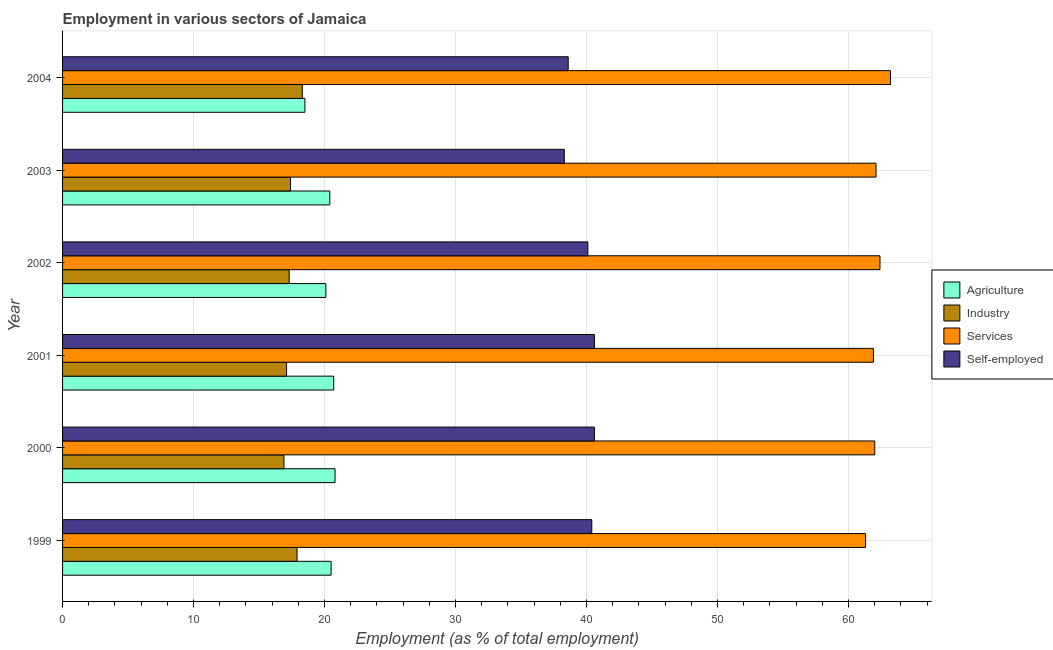How many different coloured bars are there?
Your answer should be very brief. 4. Are the number of bars per tick equal to the number of legend labels?
Provide a succinct answer. Yes. How many bars are there on the 1st tick from the top?
Provide a succinct answer. 4. How many bars are there on the 2nd tick from the bottom?
Give a very brief answer. 4. What is the label of the 3rd group of bars from the top?
Your response must be concise. 2002. In how many cases, is the number of bars for a given year not equal to the number of legend labels?
Offer a very short reply. 0. Across all years, what is the maximum percentage of workers in industry?
Ensure brevity in your answer.  18.3. In which year was the percentage of self employed workers maximum?
Your response must be concise. 2000. In which year was the percentage of workers in services minimum?
Offer a very short reply. 1999. What is the total percentage of workers in services in the graph?
Your response must be concise. 372.9. What is the difference between the percentage of workers in services in 2000 and that in 2003?
Ensure brevity in your answer.  -0.1. What is the difference between the percentage of self employed workers in 2000 and the percentage of workers in agriculture in 2004?
Your answer should be compact. 22.1. What is the average percentage of workers in services per year?
Your response must be concise. 62.15. In the year 2002, what is the difference between the percentage of workers in agriculture and percentage of self employed workers?
Ensure brevity in your answer.  -20. In how many years, is the percentage of workers in agriculture greater than 56 %?
Give a very brief answer. 0. What is the ratio of the percentage of workers in agriculture in 2002 to that in 2004?
Keep it short and to the point. 1.09. What is the difference between the highest and the second highest percentage of workers in industry?
Offer a terse response. 0.4. Is it the case that in every year, the sum of the percentage of self employed workers and percentage of workers in industry is greater than the sum of percentage of workers in services and percentage of workers in agriculture?
Ensure brevity in your answer.  Yes. What does the 4th bar from the top in 2004 represents?
Offer a very short reply. Agriculture. What does the 4th bar from the bottom in 2001 represents?
Ensure brevity in your answer.  Self-employed. How many bars are there?
Your response must be concise. 24. What is the difference between two consecutive major ticks on the X-axis?
Provide a succinct answer. 10. Does the graph contain grids?
Make the answer very short. Yes. Where does the legend appear in the graph?
Your answer should be very brief. Center right. How many legend labels are there?
Provide a short and direct response. 4. What is the title of the graph?
Provide a short and direct response. Employment in various sectors of Jamaica. What is the label or title of the X-axis?
Your answer should be very brief. Employment (as % of total employment). What is the Employment (as % of total employment) of Industry in 1999?
Keep it short and to the point. 17.9. What is the Employment (as % of total employment) of Services in 1999?
Provide a short and direct response. 61.3. What is the Employment (as % of total employment) in Self-employed in 1999?
Your response must be concise. 40.4. What is the Employment (as % of total employment) in Agriculture in 2000?
Your response must be concise. 20.8. What is the Employment (as % of total employment) in Industry in 2000?
Provide a succinct answer. 16.9. What is the Employment (as % of total employment) of Services in 2000?
Ensure brevity in your answer.  62. What is the Employment (as % of total employment) of Self-employed in 2000?
Your response must be concise. 40.6. What is the Employment (as % of total employment) in Agriculture in 2001?
Provide a short and direct response. 20.7. What is the Employment (as % of total employment) of Industry in 2001?
Provide a short and direct response. 17.1. What is the Employment (as % of total employment) in Services in 2001?
Your response must be concise. 61.9. What is the Employment (as % of total employment) in Self-employed in 2001?
Keep it short and to the point. 40.6. What is the Employment (as % of total employment) of Agriculture in 2002?
Provide a succinct answer. 20.1. What is the Employment (as % of total employment) in Industry in 2002?
Give a very brief answer. 17.3. What is the Employment (as % of total employment) in Services in 2002?
Keep it short and to the point. 62.4. What is the Employment (as % of total employment) in Self-employed in 2002?
Provide a succinct answer. 40.1. What is the Employment (as % of total employment) in Agriculture in 2003?
Give a very brief answer. 20.4. What is the Employment (as % of total employment) in Industry in 2003?
Keep it short and to the point. 17.4. What is the Employment (as % of total employment) of Services in 2003?
Your answer should be compact. 62.1. What is the Employment (as % of total employment) in Self-employed in 2003?
Give a very brief answer. 38.3. What is the Employment (as % of total employment) of Agriculture in 2004?
Make the answer very short. 18.5. What is the Employment (as % of total employment) of Industry in 2004?
Offer a terse response. 18.3. What is the Employment (as % of total employment) of Services in 2004?
Offer a very short reply. 63.2. What is the Employment (as % of total employment) of Self-employed in 2004?
Offer a terse response. 38.6. Across all years, what is the maximum Employment (as % of total employment) of Agriculture?
Ensure brevity in your answer.  20.8. Across all years, what is the maximum Employment (as % of total employment) in Industry?
Provide a short and direct response. 18.3. Across all years, what is the maximum Employment (as % of total employment) of Services?
Keep it short and to the point. 63.2. Across all years, what is the maximum Employment (as % of total employment) of Self-employed?
Offer a very short reply. 40.6. Across all years, what is the minimum Employment (as % of total employment) of Industry?
Keep it short and to the point. 16.9. Across all years, what is the minimum Employment (as % of total employment) in Services?
Offer a terse response. 61.3. Across all years, what is the minimum Employment (as % of total employment) in Self-employed?
Your answer should be compact. 38.3. What is the total Employment (as % of total employment) of Agriculture in the graph?
Provide a succinct answer. 121. What is the total Employment (as % of total employment) in Industry in the graph?
Keep it short and to the point. 104.9. What is the total Employment (as % of total employment) of Services in the graph?
Offer a terse response. 372.9. What is the total Employment (as % of total employment) of Self-employed in the graph?
Offer a very short reply. 238.6. What is the difference between the Employment (as % of total employment) of Services in 1999 and that in 2000?
Give a very brief answer. -0.7. What is the difference between the Employment (as % of total employment) in Industry in 1999 and that in 2001?
Offer a terse response. 0.8. What is the difference between the Employment (as % of total employment) in Agriculture in 1999 and that in 2002?
Provide a succinct answer. 0.4. What is the difference between the Employment (as % of total employment) in Industry in 1999 and that in 2002?
Provide a succinct answer. 0.6. What is the difference between the Employment (as % of total employment) in Self-employed in 1999 and that in 2002?
Keep it short and to the point. 0.3. What is the difference between the Employment (as % of total employment) of Agriculture in 1999 and that in 2003?
Provide a short and direct response. 0.1. What is the difference between the Employment (as % of total employment) in Industry in 1999 and that in 2003?
Your answer should be compact. 0.5. What is the difference between the Employment (as % of total employment) of Self-employed in 1999 and that in 2003?
Your answer should be compact. 2.1. What is the difference between the Employment (as % of total employment) in Industry in 1999 and that in 2004?
Ensure brevity in your answer.  -0.4. What is the difference between the Employment (as % of total employment) in Self-employed in 1999 and that in 2004?
Ensure brevity in your answer.  1.8. What is the difference between the Employment (as % of total employment) in Industry in 2000 and that in 2001?
Keep it short and to the point. -0.2. What is the difference between the Employment (as % of total employment) of Services in 2000 and that in 2001?
Provide a succinct answer. 0.1. What is the difference between the Employment (as % of total employment) in Agriculture in 2000 and that in 2002?
Provide a succinct answer. 0.7. What is the difference between the Employment (as % of total employment) in Industry in 2000 and that in 2002?
Your response must be concise. -0.4. What is the difference between the Employment (as % of total employment) in Self-employed in 2000 and that in 2002?
Provide a succinct answer. 0.5. What is the difference between the Employment (as % of total employment) of Agriculture in 2000 and that in 2003?
Provide a short and direct response. 0.4. What is the difference between the Employment (as % of total employment) of Self-employed in 2000 and that in 2003?
Ensure brevity in your answer.  2.3. What is the difference between the Employment (as % of total employment) in Agriculture in 2000 and that in 2004?
Ensure brevity in your answer.  2.3. What is the difference between the Employment (as % of total employment) in Industry in 2000 and that in 2004?
Make the answer very short. -1.4. What is the difference between the Employment (as % of total employment) in Industry in 2001 and that in 2002?
Give a very brief answer. -0.2. What is the difference between the Employment (as % of total employment) in Services in 2001 and that in 2002?
Your response must be concise. -0.5. What is the difference between the Employment (as % of total employment) of Self-employed in 2001 and that in 2002?
Offer a very short reply. 0.5. What is the difference between the Employment (as % of total employment) of Agriculture in 2001 and that in 2004?
Your response must be concise. 2.2. What is the difference between the Employment (as % of total employment) in Industry in 2002 and that in 2003?
Your answer should be compact. -0.1. What is the difference between the Employment (as % of total employment) of Services in 2002 and that in 2003?
Ensure brevity in your answer.  0.3. What is the difference between the Employment (as % of total employment) in Services in 2002 and that in 2004?
Your answer should be very brief. -0.8. What is the difference between the Employment (as % of total employment) in Services in 2003 and that in 2004?
Provide a short and direct response. -1.1. What is the difference between the Employment (as % of total employment) of Self-employed in 2003 and that in 2004?
Keep it short and to the point. -0.3. What is the difference between the Employment (as % of total employment) in Agriculture in 1999 and the Employment (as % of total employment) in Industry in 2000?
Offer a very short reply. 3.6. What is the difference between the Employment (as % of total employment) in Agriculture in 1999 and the Employment (as % of total employment) in Services in 2000?
Provide a succinct answer. -41.5. What is the difference between the Employment (as % of total employment) of Agriculture in 1999 and the Employment (as % of total employment) of Self-employed in 2000?
Keep it short and to the point. -20.1. What is the difference between the Employment (as % of total employment) in Industry in 1999 and the Employment (as % of total employment) in Services in 2000?
Offer a terse response. -44.1. What is the difference between the Employment (as % of total employment) of Industry in 1999 and the Employment (as % of total employment) of Self-employed in 2000?
Keep it short and to the point. -22.7. What is the difference between the Employment (as % of total employment) of Services in 1999 and the Employment (as % of total employment) of Self-employed in 2000?
Provide a succinct answer. 20.7. What is the difference between the Employment (as % of total employment) of Agriculture in 1999 and the Employment (as % of total employment) of Industry in 2001?
Your response must be concise. 3.4. What is the difference between the Employment (as % of total employment) of Agriculture in 1999 and the Employment (as % of total employment) of Services in 2001?
Your answer should be compact. -41.4. What is the difference between the Employment (as % of total employment) of Agriculture in 1999 and the Employment (as % of total employment) of Self-employed in 2001?
Ensure brevity in your answer.  -20.1. What is the difference between the Employment (as % of total employment) in Industry in 1999 and the Employment (as % of total employment) in Services in 2001?
Make the answer very short. -44. What is the difference between the Employment (as % of total employment) of Industry in 1999 and the Employment (as % of total employment) of Self-employed in 2001?
Offer a very short reply. -22.7. What is the difference between the Employment (as % of total employment) of Services in 1999 and the Employment (as % of total employment) of Self-employed in 2001?
Provide a short and direct response. 20.7. What is the difference between the Employment (as % of total employment) in Agriculture in 1999 and the Employment (as % of total employment) in Industry in 2002?
Make the answer very short. 3.2. What is the difference between the Employment (as % of total employment) in Agriculture in 1999 and the Employment (as % of total employment) in Services in 2002?
Offer a very short reply. -41.9. What is the difference between the Employment (as % of total employment) in Agriculture in 1999 and the Employment (as % of total employment) in Self-employed in 2002?
Keep it short and to the point. -19.6. What is the difference between the Employment (as % of total employment) in Industry in 1999 and the Employment (as % of total employment) in Services in 2002?
Provide a succinct answer. -44.5. What is the difference between the Employment (as % of total employment) in Industry in 1999 and the Employment (as % of total employment) in Self-employed in 2002?
Provide a short and direct response. -22.2. What is the difference between the Employment (as % of total employment) of Services in 1999 and the Employment (as % of total employment) of Self-employed in 2002?
Keep it short and to the point. 21.2. What is the difference between the Employment (as % of total employment) of Agriculture in 1999 and the Employment (as % of total employment) of Industry in 2003?
Offer a very short reply. 3.1. What is the difference between the Employment (as % of total employment) of Agriculture in 1999 and the Employment (as % of total employment) of Services in 2003?
Your answer should be compact. -41.6. What is the difference between the Employment (as % of total employment) in Agriculture in 1999 and the Employment (as % of total employment) in Self-employed in 2003?
Your answer should be compact. -17.8. What is the difference between the Employment (as % of total employment) in Industry in 1999 and the Employment (as % of total employment) in Services in 2003?
Make the answer very short. -44.2. What is the difference between the Employment (as % of total employment) of Industry in 1999 and the Employment (as % of total employment) of Self-employed in 2003?
Ensure brevity in your answer.  -20.4. What is the difference between the Employment (as % of total employment) of Services in 1999 and the Employment (as % of total employment) of Self-employed in 2003?
Make the answer very short. 23. What is the difference between the Employment (as % of total employment) of Agriculture in 1999 and the Employment (as % of total employment) of Services in 2004?
Your answer should be compact. -42.7. What is the difference between the Employment (as % of total employment) of Agriculture in 1999 and the Employment (as % of total employment) of Self-employed in 2004?
Your answer should be compact. -18.1. What is the difference between the Employment (as % of total employment) in Industry in 1999 and the Employment (as % of total employment) in Services in 2004?
Offer a very short reply. -45.3. What is the difference between the Employment (as % of total employment) of Industry in 1999 and the Employment (as % of total employment) of Self-employed in 2004?
Your answer should be very brief. -20.7. What is the difference between the Employment (as % of total employment) in Services in 1999 and the Employment (as % of total employment) in Self-employed in 2004?
Your response must be concise. 22.7. What is the difference between the Employment (as % of total employment) in Agriculture in 2000 and the Employment (as % of total employment) in Services in 2001?
Keep it short and to the point. -41.1. What is the difference between the Employment (as % of total employment) of Agriculture in 2000 and the Employment (as % of total employment) of Self-employed in 2001?
Offer a very short reply. -19.8. What is the difference between the Employment (as % of total employment) of Industry in 2000 and the Employment (as % of total employment) of Services in 2001?
Provide a succinct answer. -45. What is the difference between the Employment (as % of total employment) in Industry in 2000 and the Employment (as % of total employment) in Self-employed in 2001?
Give a very brief answer. -23.7. What is the difference between the Employment (as % of total employment) of Services in 2000 and the Employment (as % of total employment) of Self-employed in 2001?
Provide a succinct answer. 21.4. What is the difference between the Employment (as % of total employment) of Agriculture in 2000 and the Employment (as % of total employment) of Services in 2002?
Provide a short and direct response. -41.6. What is the difference between the Employment (as % of total employment) of Agriculture in 2000 and the Employment (as % of total employment) of Self-employed in 2002?
Provide a succinct answer. -19.3. What is the difference between the Employment (as % of total employment) of Industry in 2000 and the Employment (as % of total employment) of Services in 2002?
Make the answer very short. -45.5. What is the difference between the Employment (as % of total employment) of Industry in 2000 and the Employment (as % of total employment) of Self-employed in 2002?
Provide a succinct answer. -23.2. What is the difference between the Employment (as % of total employment) in Services in 2000 and the Employment (as % of total employment) in Self-employed in 2002?
Offer a very short reply. 21.9. What is the difference between the Employment (as % of total employment) of Agriculture in 2000 and the Employment (as % of total employment) of Services in 2003?
Give a very brief answer. -41.3. What is the difference between the Employment (as % of total employment) in Agriculture in 2000 and the Employment (as % of total employment) in Self-employed in 2003?
Offer a very short reply. -17.5. What is the difference between the Employment (as % of total employment) of Industry in 2000 and the Employment (as % of total employment) of Services in 2003?
Provide a short and direct response. -45.2. What is the difference between the Employment (as % of total employment) in Industry in 2000 and the Employment (as % of total employment) in Self-employed in 2003?
Your response must be concise. -21.4. What is the difference between the Employment (as % of total employment) of Services in 2000 and the Employment (as % of total employment) of Self-employed in 2003?
Provide a short and direct response. 23.7. What is the difference between the Employment (as % of total employment) in Agriculture in 2000 and the Employment (as % of total employment) in Services in 2004?
Keep it short and to the point. -42.4. What is the difference between the Employment (as % of total employment) in Agriculture in 2000 and the Employment (as % of total employment) in Self-employed in 2004?
Make the answer very short. -17.8. What is the difference between the Employment (as % of total employment) in Industry in 2000 and the Employment (as % of total employment) in Services in 2004?
Give a very brief answer. -46.3. What is the difference between the Employment (as % of total employment) in Industry in 2000 and the Employment (as % of total employment) in Self-employed in 2004?
Provide a succinct answer. -21.7. What is the difference between the Employment (as % of total employment) of Services in 2000 and the Employment (as % of total employment) of Self-employed in 2004?
Offer a very short reply. 23.4. What is the difference between the Employment (as % of total employment) in Agriculture in 2001 and the Employment (as % of total employment) in Services in 2002?
Ensure brevity in your answer.  -41.7. What is the difference between the Employment (as % of total employment) of Agriculture in 2001 and the Employment (as % of total employment) of Self-employed in 2002?
Offer a terse response. -19.4. What is the difference between the Employment (as % of total employment) in Industry in 2001 and the Employment (as % of total employment) in Services in 2002?
Your response must be concise. -45.3. What is the difference between the Employment (as % of total employment) of Industry in 2001 and the Employment (as % of total employment) of Self-employed in 2002?
Provide a short and direct response. -23. What is the difference between the Employment (as % of total employment) in Services in 2001 and the Employment (as % of total employment) in Self-employed in 2002?
Provide a succinct answer. 21.8. What is the difference between the Employment (as % of total employment) in Agriculture in 2001 and the Employment (as % of total employment) in Services in 2003?
Give a very brief answer. -41.4. What is the difference between the Employment (as % of total employment) of Agriculture in 2001 and the Employment (as % of total employment) of Self-employed in 2003?
Ensure brevity in your answer.  -17.6. What is the difference between the Employment (as % of total employment) of Industry in 2001 and the Employment (as % of total employment) of Services in 2003?
Offer a terse response. -45. What is the difference between the Employment (as % of total employment) of Industry in 2001 and the Employment (as % of total employment) of Self-employed in 2003?
Ensure brevity in your answer.  -21.2. What is the difference between the Employment (as % of total employment) in Services in 2001 and the Employment (as % of total employment) in Self-employed in 2003?
Your response must be concise. 23.6. What is the difference between the Employment (as % of total employment) of Agriculture in 2001 and the Employment (as % of total employment) of Services in 2004?
Make the answer very short. -42.5. What is the difference between the Employment (as % of total employment) of Agriculture in 2001 and the Employment (as % of total employment) of Self-employed in 2004?
Your response must be concise. -17.9. What is the difference between the Employment (as % of total employment) in Industry in 2001 and the Employment (as % of total employment) in Services in 2004?
Your response must be concise. -46.1. What is the difference between the Employment (as % of total employment) in Industry in 2001 and the Employment (as % of total employment) in Self-employed in 2004?
Provide a short and direct response. -21.5. What is the difference between the Employment (as % of total employment) of Services in 2001 and the Employment (as % of total employment) of Self-employed in 2004?
Provide a short and direct response. 23.3. What is the difference between the Employment (as % of total employment) of Agriculture in 2002 and the Employment (as % of total employment) of Services in 2003?
Offer a very short reply. -42. What is the difference between the Employment (as % of total employment) of Agriculture in 2002 and the Employment (as % of total employment) of Self-employed in 2003?
Provide a succinct answer. -18.2. What is the difference between the Employment (as % of total employment) of Industry in 2002 and the Employment (as % of total employment) of Services in 2003?
Ensure brevity in your answer.  -44.8. What is the difference between the Employment (as % of total employment) in Industry in 2002 and the Employment (as % of total employment) in Self-employed in 2003?
Provide a short and direct response. -21. What is the difference between the Employment (as % of total employment) in Services in 2002 and the Employment (as % of total employment) in Self-employed in 2003?
Your answer should be compact. 24.1. What is the difference between the Employment (as % of total employment) in Agriculture in 2002 and the Employment (as % of total employment) in Services in 2004?
Ensure brevity in your answer.  -43.1. What is the difference between the Employment (as % of total employment) of Agriculture in 2002 and the Employment (as % of total employment) of Self-employed in 2004?
Keep it short and to the point. -18.5. What is the difference between the Employment (as % of total employment) in Industry in 2002 and the Employment (as % of total employment) in Services in 2004?
Offer a terse response. -45.9. What is the difference between the Employment (as % of total employment) in Industry in 2002 and the Employment (as % of total employment) in Self-employed in 2004?
Your answer should be compact. -21.3. What is the difference between the Employment (as % of total employment) in Services in 2002 and the Employment (as % of total employment) in Self-employed in 2004?
Keep it short and to the point. 23.8. What is the difference between the Employment (as % of total employment) in Agriculture in 2003 and the Employment (as % of total employment) in Industry in 2004?
Make the answer very short. 2.1. What is the difference between the Employment (as % of total employment) of Agriculture in 2003 and the Employment (as % of total employment) of Services in 2004?
Offer a very short reply. -42.8. What is the difference between the Employment (as % of total employment) in Agriculture in 2003 and the Employment (as % of total employment) in Self-employed in 2004?
Your answer should be very brief. -18.2. What is the difference between the Employment (as % of total employment) of Industry in 2003 and the Employment (as % of total employment) of Services in 2004?
Your answer should be very brief. -45.8. What is the difference between the Employment (as % of total employment) in Industry in 2003 and the Employment (as % of total employment) in Self-employed in 2004?
Your answer should be very brief. -21.2. What is the difference between the Employment (as % of total employment) in Services in 2003 and the Employment (as % of total employment) in Self-employed in 2004?
Offer a terse response. 23.5. What is the average Employment (as % of total employment) in Agriculture per year?
Make the answer very short. 20.17. What is the average Employment (as % of total employment) in Industry per year?
Your response must be concise. 17.48. What is the average Employment (as % of total employment) of Services per year?
Make the answer very short. 62.15. What is the average Employment (as % of total employment) in Self-employed per year?
Your answer should be very brief. 39.77. In the year 1999, what is the difference between the Employment (as % of total employment) in Agriculture and Employment (as % of total employment) in Industry?
Ensure brevity in your answer.  2.6. In the year 1999, what is the difference between the Employment (as % of total employment) of Agriculture and Employment (as % of total employment) of Services?
Ensure brevity in your answer.  -40.8. In the year 1999, what is the difference between the Employment (as % of total employment) of Agriculture and Employment (as % of total employment) of Self-employed?
Offer a terse response. -19.9. In the year 1999, what is the difference between the Employment (as % of total employment) of Industry and Employment (as % of total employment) of Services?
Offer a very short reply. -43.4. In the year 1999, what is the difference between the Employment (as % of total employment) in Industry and Employment (as % of total employment) in Self-employed?
Offer a terse response. -22.5. In the year 1999, what is the difference between the Employment (as % of total employment) of Services and Employment (as % of total employment) of Self-employed?
Offer a terse response. 20.9. In the year 2000, what is the difference between the Employment (as % of total employment) of Agriculture and Employment (as % of total employment) of Services?
Make the answer very short. -41.2. In the year 2000, what is the difference between the Employment (as % of total employment) of Agriculture and Employment (as % of total employment) of Self-employed?
Your answer should be compact. -19.8. In the year 2000, what is the difference between the Employment (as % of total employment) in Industry and Employment (as % of total employment) in Services?
Ensure brevity in your answer.  -45.1. In the year 2000, what is the difference between the Employment (as % of total employment) in Industry and Employment (as % of total employment) in Self-employed?
Give a very brief answer. -23.7. In the year 2000, what is the difference between the Employment (as % of total employment) in Services and Employment (as % of total employment) in Self-employed?
Make the answer very short. 21.4. In the year 2001, what is the difference between the Employment (as % of total employment) of Agriculture and Employment (as % of total employment) of Industry?
Make the answer very short. 3.6. In the year 2001, what is the difference between the Employment (as % of total employment) of Agriculture and Employment (as % of total employment) of Services?
Make the answer very short. -41.2. In the year 2001, what is the difference between the Employment (as % of total employment) in Agriculture and Employment (as % of total employment) in Self-employed?
Provide a succinct answer. -19.9. In the year 2001, what is the difference between the Employment (as % of total employment) of Industry and Employment (as % of total employment) of Services?
Your answer should be very brief. -44.8. In the year 2001, what is the difference between the Employment (as % of total employment) of Industry and Employment (as % of total employment) of Self-employed?
Your answer should be very brief. -23.5. In the year 2001, what is the difference between the Employment (as % of total employment) in Services and Employment (as % of total employment) in Self-employed?
Keep it short and to the point. 21.3. In the year 2002, what is the difference between the Employment (as % of total employment) in Agriculture and Employment (as % of total employment) in Industry?
Make the answer very short. 2.8. In the year 2002, what is the difference between the Employment (as % of total employment) of Agriculture and Employment (as % of total employment) of Services?
Provide a short and direct response. -42.3. In the year 2002, what is the difference between the Employment (as % of total employment) of Agriculture and Employment (as % of total employment) of Self-employed?
Make the answer very short. -20. In the year 2002, what is the difference between the Employment (as % of total employment) of Industry and Employment (as % of total employment) of Services?
Your answer should be very brief. -45.1. In the year 2002, what is the difference between the Employment (as % of total employment) of Industry and Employment (as % of total employment) of Self-employed?
Offer a very short reply. -22.8. In the year 2002, what is the difference between the Employment (as % of total employment) in Services and Employment (as % of total employment) in Self-employed?
Make the answer very short. 22.3. In the year 2003, what is the difference between the Employment (as % of total employment) in Agriculture and Employment (as % of total employment) in Services?
Keep it short and to the point. -41.7. In the year 2003, what is the difference between the Employment (as % of total employment) in Agriculture and Employment (as % of total employment) in Self-employed?
Provide a short and direct response. -17.9. In the year 2003, what is the difference between the Employment (as % of total employment) in Industry and Employment (as % of total employment) in Services?
Your response must be concise. -44.7. In the year 2003, what is the difference between the Employment (as % of total employment) in Industry and Employment (as % of total employment) in Self-employed?
Keep it short and to the point. -20.9. In the year 2003, what is the difference between the Employment (as % of total employment) in Services and Employment (as % of total employment) in Self-employed?
Your answer should be compact. 23.8. In the year 2004, what is the difference between the Employment (as % of total employment) in Agriculture and Employment (as % of total employment) in Industry?
Provide a succinct answer. 0.2. In the year 2004, what is the difference between the Employment (as % of total employment) in Agriculture and Employment (as % of total employment) in Services?
Ensure brevity in your answer.  -44.7. In the year 2004, what is the difference between the Employment (as % of total employment) in Agriculture and Employment (as % of total employment) in Self-employed?
Provide a succinct answer. -20.1. In the year 2004, what is the difference between the Employment (as % of total employment) of Industry and Employment (as % of total employment) of Services?
Make the answer very short. -44.9. In the year 2004, what is the difference between the Employment (as % of total employment) in Industry and Employment (as % of total employment) in Self-employed?
Ensure brevity in your answer.  -20.3. In the year 2004, what is the difference between the Employment (as % of total employment) of Services and Employment (as % of total employment) of Self-employed?
Your answer should be very brief. 24.6. What is the ratio of the Employment (as % of total employment) of Agriculture in 1999 to that in 2000?
Offer a very short reply. 0.99. What is the ratio of the Employment (as % of total employment) of Industry in 1999 to that in 2000?
Give a very brief answer. 1.06. What is the ratio of the Employment (as % of total employment) in Services in 1999 to that in 2000?
Ensure brevity in your answer.  0.99. What is the ratio of the Employment (as % of total employment) of Agriculture in 1999 to that in 2001?
Keep it short and to the point. 0.99. What is the ratio of the Employment (as % of total employment) of Industry in 1999 to that in 2001?
Your answer should be very brief. 1.05. What is the ratio of the Employment (as % of total employment) of Services in 1999 to that in 2001?
Your answer should be compact. 0.99. What is the ratio of the Employment (as % of total employment) of Self-employed in 1999 to that in 2001?
Keep it short and to the point. 1. What is the ratio of the Employment (as % of total employment) in Agriculture in 1999 to that in 2002?
Make the answer very short. 1.02. What is the ratio of the Employment (as % of total employment) in Industry in 1999 to that in 2002?
Make the answer very short. 1.03. What is the ratio of the Employment (as % of total employment) in Services in 1999 to that in 2002?
Your response must be concise. 0.98. What is the ratio of the Employment (as % of total employment) of Self-employed in 1999 to that in 2002?
Your response must be concise. 1.01. What is the ratio of the Employment (as % of total employment) in Industry in 1999 to that in 2003?
Your answer should be very brief. 1.03. What is the ratio of the Employment (as % of total employment) in Services in 1999 to that in 2003?
Ensure brevity in your answer.  0.99. What is the ratio of the Employment (as % of total employment) of Self-employed in 1999 to that in 2003?
Offer a terse response. 1.05. What is the ratio of the Employment (as % of total employment) of Agriculture in 1999 to that in 2004?
Offer a very short reply. 1.11. What is the ratio of the Employment (as % of total employment) of Industry in 1999 to that in 2004?
Make the answer very short. 0.98. What is the ratio of the Employment (as % of total employment) of Services in 1999 to that in 2004?
Make the answer very short. 0.97. What is the ratio of the Employment (as % of total employment) of Self-employed in 1999 to that in 2004?
Give a very brief answer. 1.05. What is the ratio of the Employment (as % of total employment) in Industry in 2000 to that in 2001?
Your answer should be very brief. 0.99. What is the ratio of the Employment (as % of total employment) in Agriculture in 2000 to that in 2002?
Your answer should be compact. 1.03. What is the ratio of the Employment (as % of total employment) in Industry in 2000 to that in 2002?
Provide a short and direct response. 0.98. What is the ratio of the Employment (as % of total employment) of Services in 2000 to that in 2002?
Offer a terse response. 0.99. What is the ratio of the Employment (as % of total employment) of Self-employed in 2000 to that in 2002?
Provide a succinct answer. 1.01. What is the ratio of the Employment (as % of total employment) of Agriculture in 2000 to that in 2003?
Keep it short and to the point. 1.02. What is the ratio of the Employment (as % of total employment) in Industry in 2000 to that in 2003?
Make the answer very short. 0.97. What is the ratio of the Employment (as % of total employment) of Services in 2000 to that in 2003?
Offer a terse response. 1. What is the ratio of the Employment (as % of total employment) in Self-employed in 2000 to that in 2003?
Provide a succinct answer. 1.06. What is the ratio of the Employment (as % of total employment) of Agriculture in 2000 to that in 2004?
Your answer should be compact. 1.12. What is the ratio of the Employment (as % of total employment) in Industry in 2000 to that in 2004?
Your answer should be compact. 0.92. What is the ratio of the Employment (as % of total employment) in Self-employed in 2000 to that in 2004?
Provide a succinct answer. 1.05. What is the ratio of the Employment (as % of total employment) in Agriculture in 2001 to that in 2002?
Offer a terse response. 1.03. What is the ratio of the Employment (as % of total employment) of Industry in 2001 to that in 2002?
Make the answer very short. 0.99. What is the ratio of the Employment (as % of total employment) in Self-employed in 2001 to that in 2002?
Your answer should be compact. 1.01. What is the ratio of the Employment (as % of total employment) of Agriculture in 2001 to that in 2003?
Give a very brief answer. 1.01. What is the ratio of the Employment (as % of total employment) of Industry in 2001 to that in 2003?
Your answer should be very brief. 0.98. What is the ratio of the Employment (as % of total employment) in Self-employed in 2001 to that in 2003?
Your answer should be compact. 1.06. What is the ratio of the Employment (as % of total employment) in Agriculture in 2001 to that in 2004?
Offer a terse response. 1.12. What is the ratio of the Employment (as % of total employment) in Industry in 2001 to that in 2004?
Make the answer very short. 0.93. What is the ratio of the Employment (as % of total employment) of Services in 2001 to that in 2004?
Make the answer very short. 0.98. What is the ratio of the Employment (as % of total employment) in Self-employed in 2001 to that in 2004?
Your answer should be very brief. 1.05. What is the ratio of the Employment (as % of total employment) in Industry in 2002 to that in 2003?
Offer a very short reply. 0.99. What is the ratio of the Employment (as % of total employment) of Services in 2002 to that in 2003?
Offer a terse response. 1. What is the ratio of the Employment (as % of total employment) of Self-employed in 2002 to that in 2003?
Keep it short and to the point. 1.05. What is the ratio of the Employment (as % of total employment) in Agriculture in 2002 to that in 2004?
Ensure brevity in your answer.  1.09. What is the ratio of the Employment (as % of total employment) of Industry in 2002 to that in 2004?
Give a very brief answer. 0.95. What is the ratio of the Employment (as % of total employment) in Services in 2002 to that in 2004?
Provide a succinct answer. 0.99. What is the ratio of the Employment (as % of total employment) of Self-employed in 2002 to that in 2004?
Give a very brief answer. 1.04. What is the ratio of the Employment (as % of total employment) in Agriculture in 2003 to that in 2004?
Keep it short and to the point. 1.1. What is the ratio of the Employment (as % of total employment) of Industry in 2003 to that in 2004?
Your response must be concise. 0.95. What is the ratio of the Employment (as % of total employment) of Services in 2003 to that in 2004?
Provide a short and direct response. 0.98. What is the ratio of the Employment (as % of total employment) of Self-employed in 2003 to that in 2004?
Provide a short and direct response. 0.99. What is the difference between the highest and the lowest Employment (as % of total employment) in Services?
Your answer should be very brief. 1.9. 